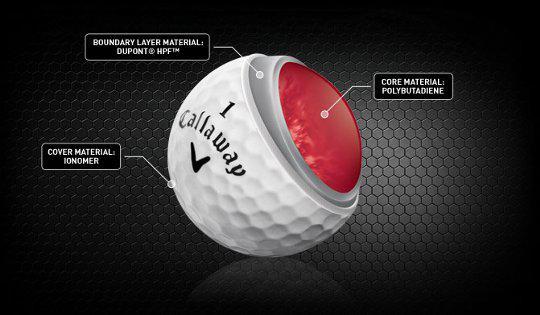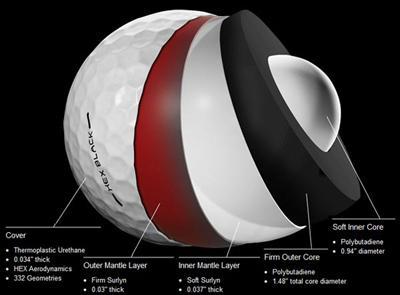The first image is the image on the left, the second image is the image on the right. For the images shown, is this caption "An image shows at least four interior layers of a white golf ball." true? Answer yes or no. Yes. The first image is the image on the left, the second image is the image on the right. Analyze the images presented: Is the assertion "Both images show the inside of a golf ball." valid? Answer yes or no. Yes. 